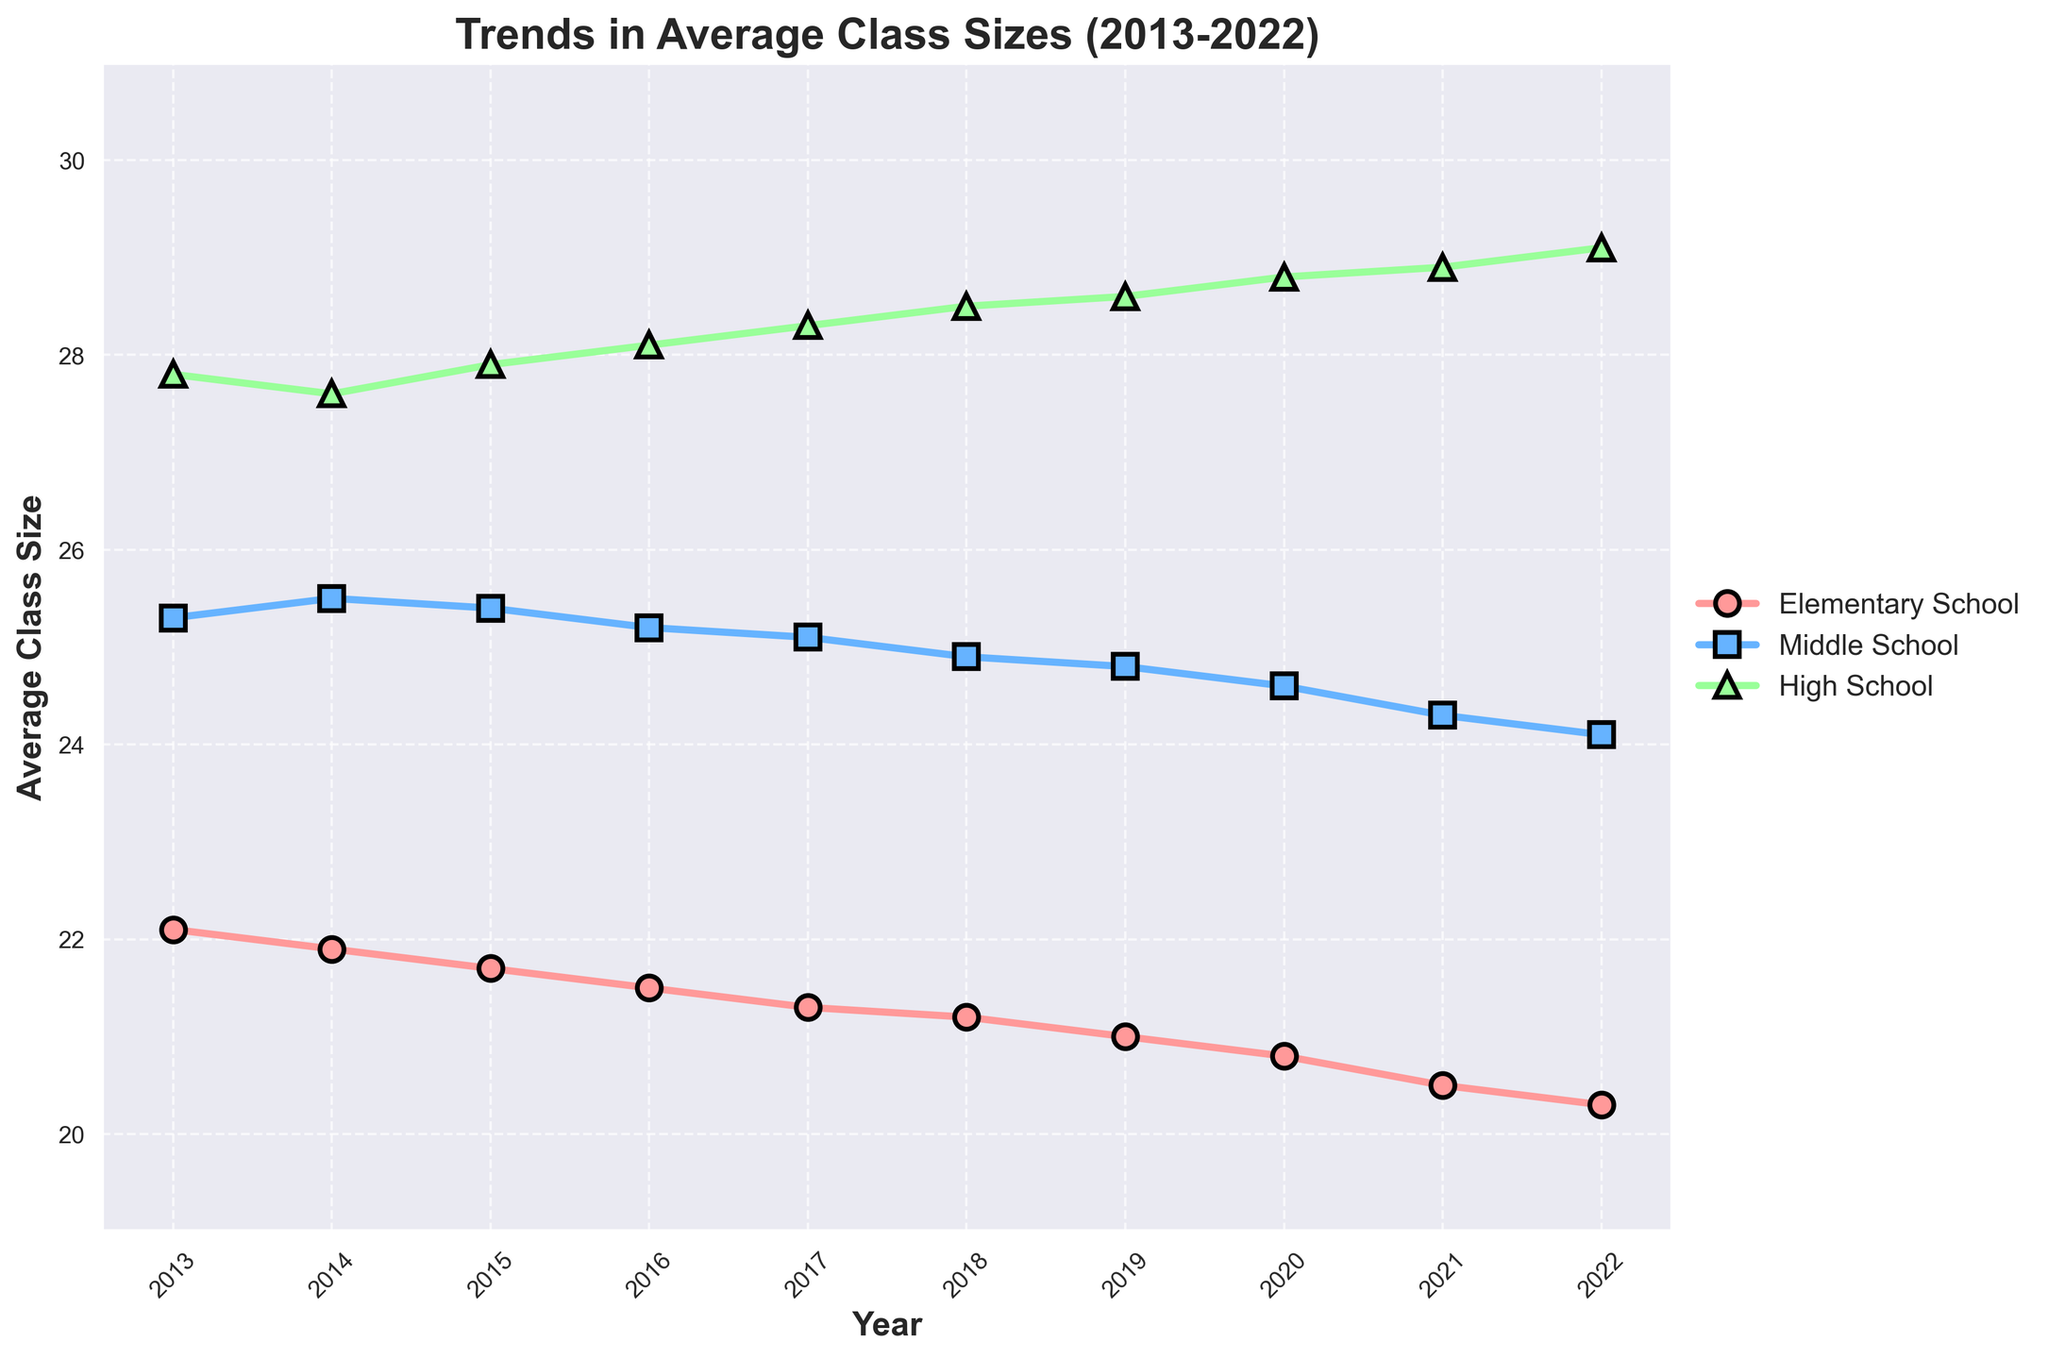What is the trend in the average class size for elementary schools from 2013 to 2022? The average class size for elementary schools decreases steadily year by year from 22.1 in 2013 to 20.3 in 2022.
Answer: The trend is a steady decrease Around which year did the average class size for middle schools drop below 25? Observing the middle school trend line, the average class size dropped below 25 around the year 2018.
Answer: Around 2018 How much did the average class size for high schools increase from 2013 to 2022? In 2013, the average class size for high schools was 27.8, and by 2022, it increased to 29.1. The increase is calculated as 29.1 - 27.8 = 1.3.
Answer: 1.3 Which grade level has the most consistent average class size throughout the decade? Observing the figure, the trend line for middle schools fluctuates the least over the years, indicating the most consistent average class size.
Answer: Middle school In 2022, how does the average class size for high schools compare to middle schools? The average class size for high schools in 2022 is 29.1, while for middle schools, it is 24.1. This shows that high schools have a larger average class size.
Answer: High school > Middle school By what percentage did the average class size for elementary schools decrease from 2013 to 2022? The average class size for elementary schools decreased from 22.1 in 2013 to 20.3 in 2022. The percentage decrease can be calculated as ((22.1 - 20.3) / 22.1) * 100 ≈ 8.14%.
Answer: ≈ 8.14% What difference in average class size can be observed between elementary schools and high schools in 2016? In 2016, the average class size was 21.5 for elementary schools and 28.1 for high schools. The difference is 28.1 - 21.5 = 6.6.
Answer: 6.6 If we consider the trend from 2013 to 2022, which grade level saw the most significant overall change in average class size? The average class size for elementary schools decreased from 22.1 to 20.3 (1.8 units), for middle schools from 25.3 to 24.1 (1.2 units), and for high schools from 27.8 to 29.1 (1.3 units). The greatest change is for elementary schools.
Answer: Elementary school What year did the average class size for middle schools and high schools have the smallest difference? The smallest difference between middle and high schools was in 2014, where the difference was 27.6 - 25.5 = 2.1.
Answer: 2014 How does the slope of the trend line for elementary schools compare to high schools from 2013 to 2022? The trend line for elementary schools has a negative slope indicating a decrease, while for high schools, it has a positive slope indicating an increase.
Answer: Elementary: negative, High school: positive 